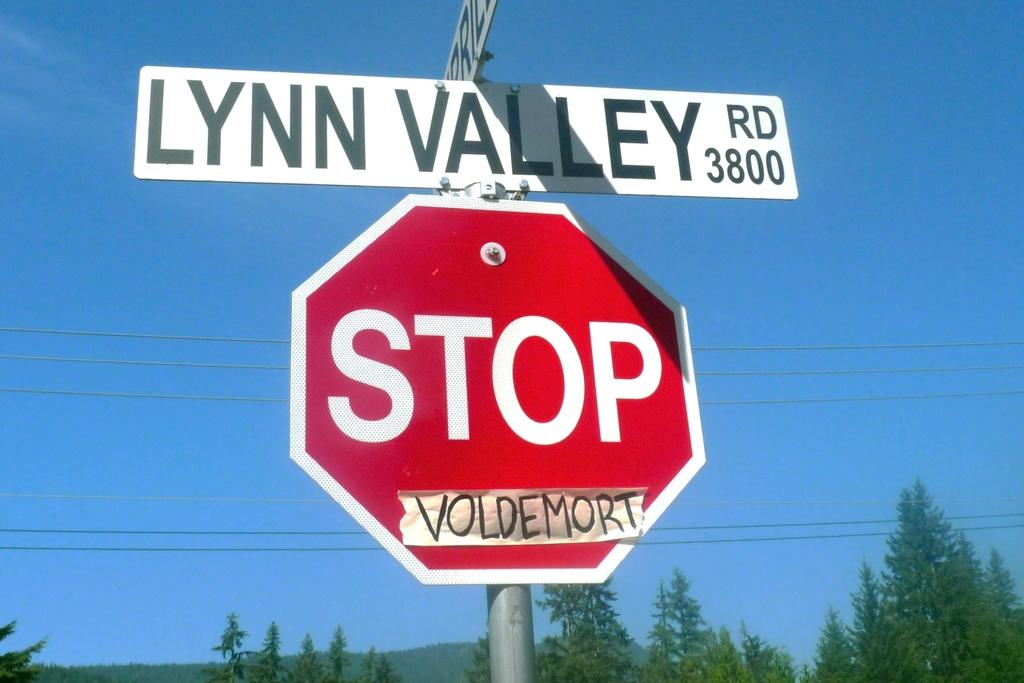<image>
Share a concise interpretation of the image provided. A red and white stop sign has tape that has the word voldemort written on it. 